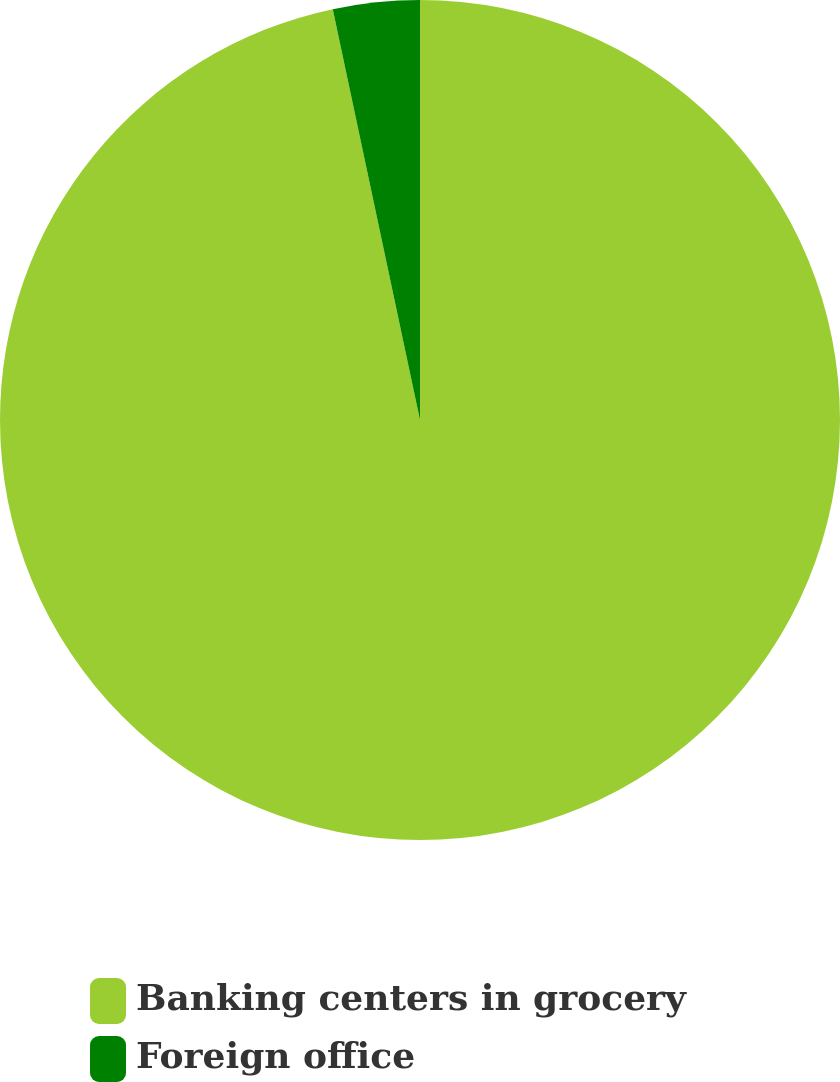Convert chart. <chart><loc_0><loc_0><loc_500><loc_500><pie_chart><fcel>Banking centers in grocery<fcel>Foreign office<nl><fcel>96.67%<fcel>3.33%<nl></chart> 